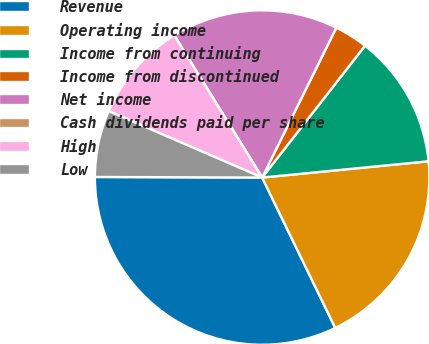<chart> <loc_0><loc_0><loc_500><loc_500><pie_chart><fcel>Revenue<fcel>Operating income<fcel>Income from continuing<fcel>Income from discontinued<fcel>Net income<fcel>Cash dividends paid per share<fcel>High<fcel>Low<nl><fcel>32.26%<fcel>19.35%<fcel>12.9%<fcel>3.23%<fcel>16.13%<fcel>0.0%<fcel>9.68%<fcel>6.45%<nl></chart> 